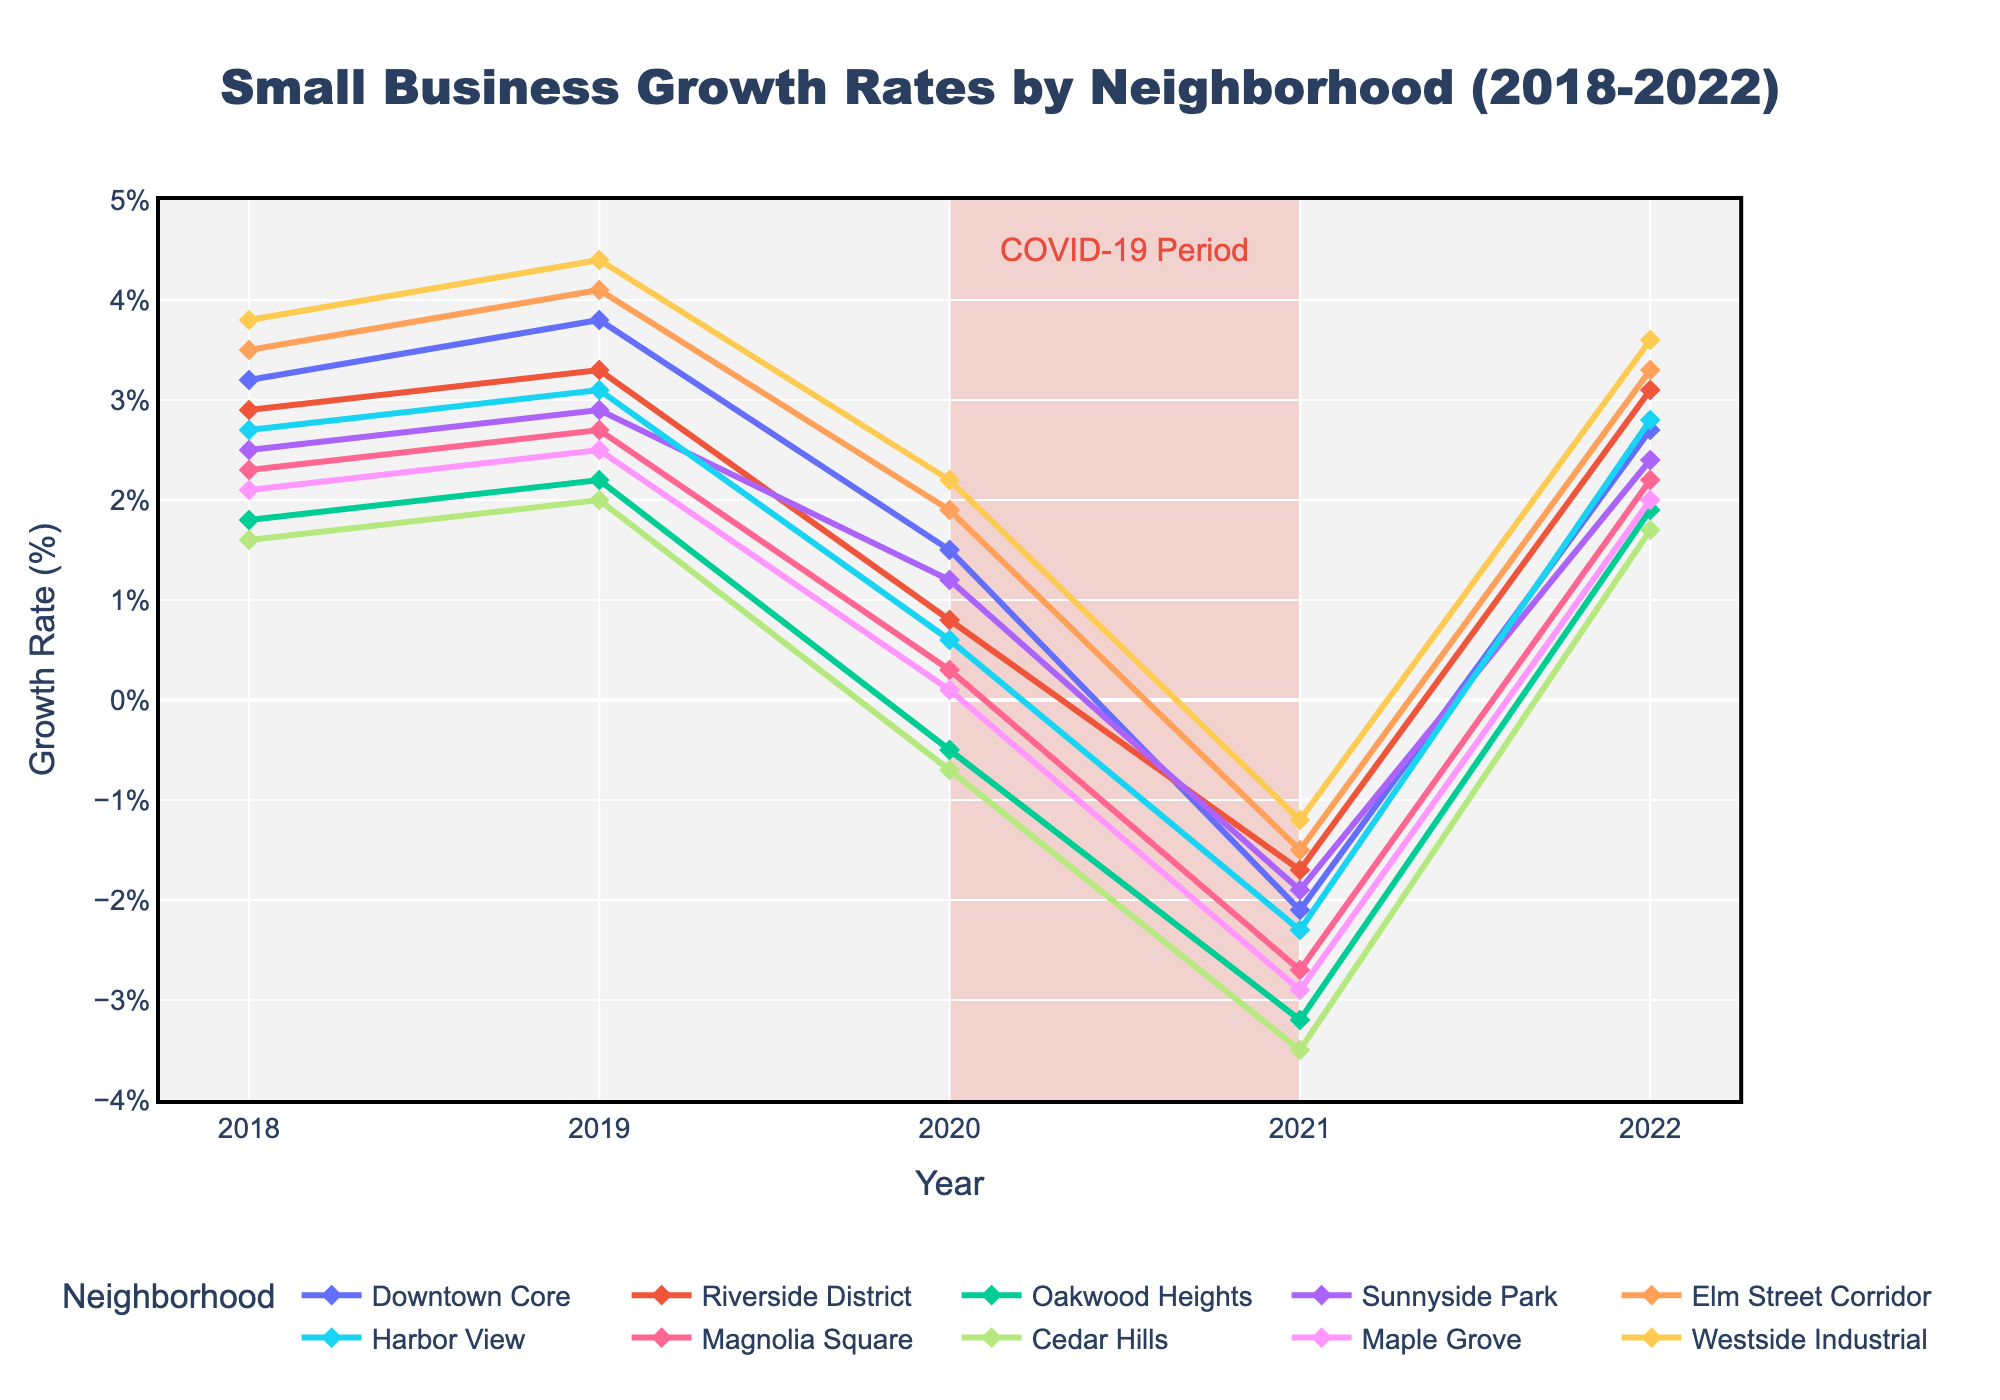What trend do most neighborhoods show between 2020 and 2021? Most neighborhoods show a negative growth rate trend between 2020 and 2021. This can be observed by looking at the dip in the growth rates across most of the lines on the chart during these years, highlighted in the shaded COVID-19 period.
Answer: Negative trend Which neighborhood experienced the highest growth rate in 2022? To find this, look at the endpoints for each line in the year 2022. The highest point in 2022 corresponds to Westside Industrial with 3.6%.
Answer: Westside Industrial Which neighborhoods had a negative growth rate in 2020? Check the y-values of the plotted lines corresponding to the year 2020. The neighborhoods with negative values are Oakwood Heights (-0.5), Cedar Hills (-0.7), and Maple Grove (0.1).
Answer: Oakwood Heights, Cedar Hills, and Maple Grove How did Elm Street Corridor's growth rate change from 2019 to 2021? For Elm Street Corridor, the growth rates are 4.1% in 2019, 1.9% in 2020, and -1.5% in 2021. The changes are:
1. 2019 to 2020: 4.1% - 1.9% = -2.2%
2. 2020 to 2021: 1.9% - (-1.5%) = 3.4%
3. Thus, the total change from 2019 to 2021 is 4.1% - (-1.5%) = -5.6%.
Answer: -5.6% Which neighborhood had the lowest growth rate in 2021, and what was the value? Look for the lowest point on the chart in the year 2021. Cedar Hills had the lowest growth rate at -3.5%.
Answer: Cedar Hills, -3.5% Compare the growth rates of Downtown Core and Riverside District in 2019. Which one was higher? Observing the lines for 2019, Downtown Core had a growth rate of 3.8%, while Riverside District had 3.3%.
Answer: Downtown Core What is the average growth rate of Sunnyside Park over the 5 years? Summing the growth rates for Sunnyside Park: 2.5 + 2.9 + 1.2 - 1.9 + 2.4 = 7.1. Dividing by 5 years, the average is 7.1 / 5 = 1.42%.
Answer: 1.42% What is the growth rate difference between Harbor View and Magnolia Square in 2020? In 2020, Harbor View had a growth rate of 0.6%, and Magnolia Square had 0.3%. The difference is 0.6% - 0.3% = 0.3%.
Answer: 0.3% Identify the neighborhoods that showed a positive growth rate in both 2018 and 2022. The neighborhoods with positive growth rates in both years are:
- Downtown Core (3.2%, 2.7%)
- Riverside District (2.9%, 3.1%)
- Sunnyside Park (2.5%, 2.4%)
- Elm Street Corridor (3.5%, 3.3%)
- Harbor View (2.7%, 2.8%)
- Westside Industrial (3.8%, 3.6%)
Answer: Downtown Core, Riverside District, Sunnyside Park, Elm Street Corridor, Harbor View, Westside Industrial 